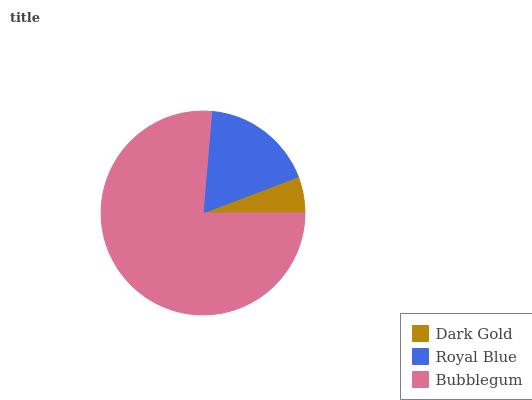Is Dark Gold the minimum?
Answer yes or no. Yes. Is Bubblegum the maximum?
Answer yes or no. Yes. Is Royal Blue the minimum?
Answer yes or no. No. Is Royal Blue the maximum?
Answer yes or no. No. Is Royal Blue greater than Dark Gold?
Answer yes or no. Yes. Is Dark Gold less than Royal Blue?
Answer yes or no. Yes. Is Dark Gold greater than Royal Blue?
Answer yes or no. No. Is Royal Blue less than Dark Gold?
Answer yes or no. No. Is Royal Blue the high median?
Answer yes or no. Yes. Is Royal Blue the low median?
Answer yes or no. Yes. Is Bubblegum the high median?
Answer yes or no. No. Is Bubblegum the low median?
Answer yes or no. No. 